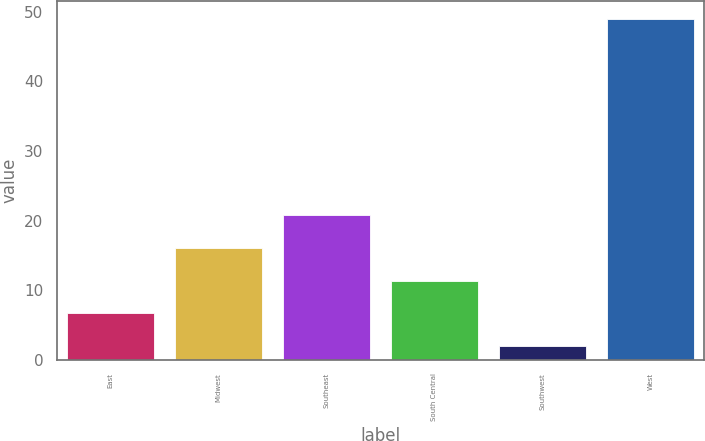Convert chart. <chart><loc_0><loc_0><loc_500><loc_500><bar_chart><fcel>East<fcel>Midwest<fcel>Southeast<fcel>South Central<fcel>Southwest<fcel>West<nl><fcel>6.7<fcel>16.1<fcel>20.8<fcel>11.4<fcel>2<fcel>49<nl></chart> 